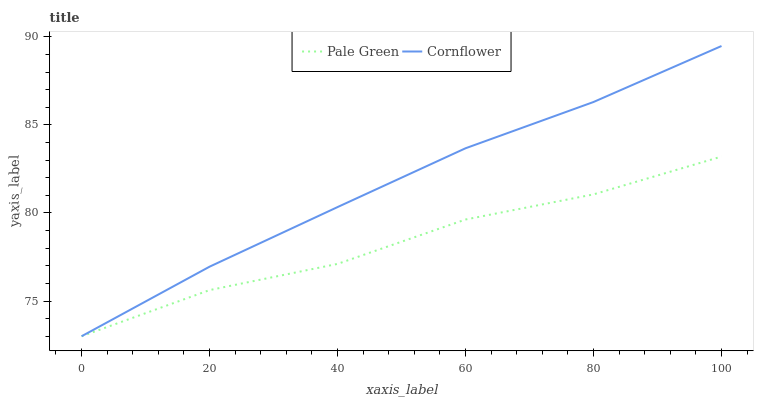Does Pale Green have the minimum area under the curve?
Answer yes or no. Yes. Does Cornflower have the maximum area under the curve?
Answer yes or no. Yes. Does Pale Green have the maximum area under the curve?
Answer yes or no. No. Is Cornflower the smoothest?
Answer yes or no. Yes. Is Pale Green the roughest?
Answer yes or no. Yes. Is Pale Green the smoothest?
Answer yes or no. No. Does Cornflower have the highest value?
Answer yes or no. Yes. Does Pale Green have the highest value?
Answer yes or no. No. Does Cornflower intersect Pale Green?
Answer yes or no. Yes. Is Cornflower less than Pale Green?
Answer yes or no. No. Is Cornflower greater than Pale Green?
Answer yes or no. No. 